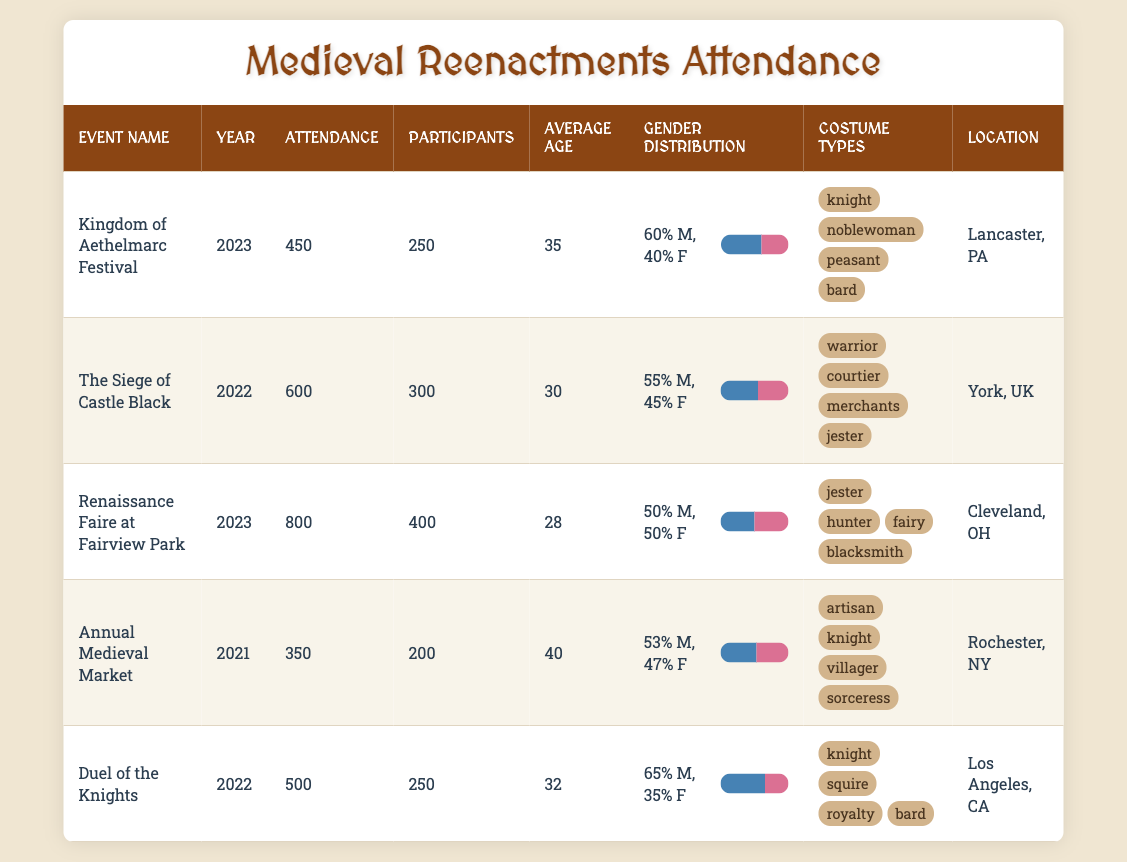What was the highest attendance recorded at a medieval reenactment event? Checking the attendance values in the table, the highest attendance is 800 at the Renaissance Faire at Fairview Park in 2023.
Answer: 800 Which event had the largest gender disparity favoring males in attendance? By examining the gender distribution percentages, the event with the largest male percentage is the Duel of the Knights with 65% males compared to 35% females.
Answer: Duel of the Knights What is the average age of participants across all events listed? To calculate the average age, sum the average ages (35 + 30 + 28 + 40 + 32) = 165, and then divide by the number of events (5). Thus, 165/5 = 33.
Answer: 33 Did the Kingdom of Aethelmarc Festival have more attendees or participants? The Kingdom of Aethelmarc Festival had an attendance of 450 and participants of 250. Since 450 is greater than 250, the event had more attendees than participants.
Answer: Yes Which event took place in the year 2022 and had a lower average age than the Duel of the Knights? The Duel of the Knights has an average age of 32. The Siege of Castle Black, which took place in 2022, has an average age of 30, which is lower than 32.
Answer: The Siege of Castle Black 